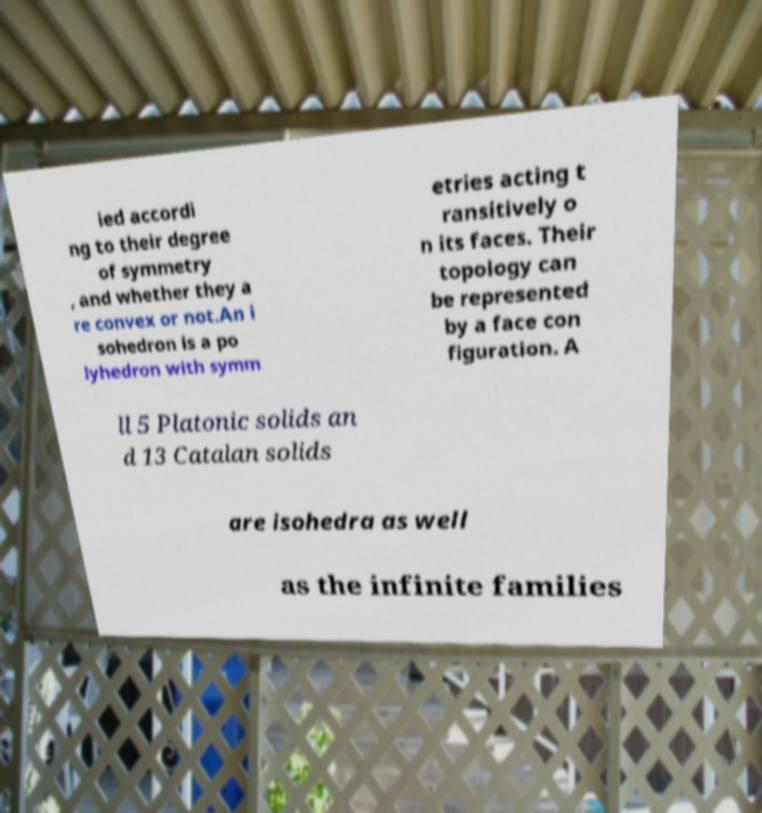What messages or text are displayed in this image? I need them in a readable, typed format. ied accordi ng to their degree of symmetry , and whether they a re convex or not.An i sohedron is a po lyhedron with symm etries acting t ransitively o n its faces. Their topology can be represented by a face con figuration. A ll 5 Platonic solids an d 13 Catalan solids are isohedra as well as the infinite families 